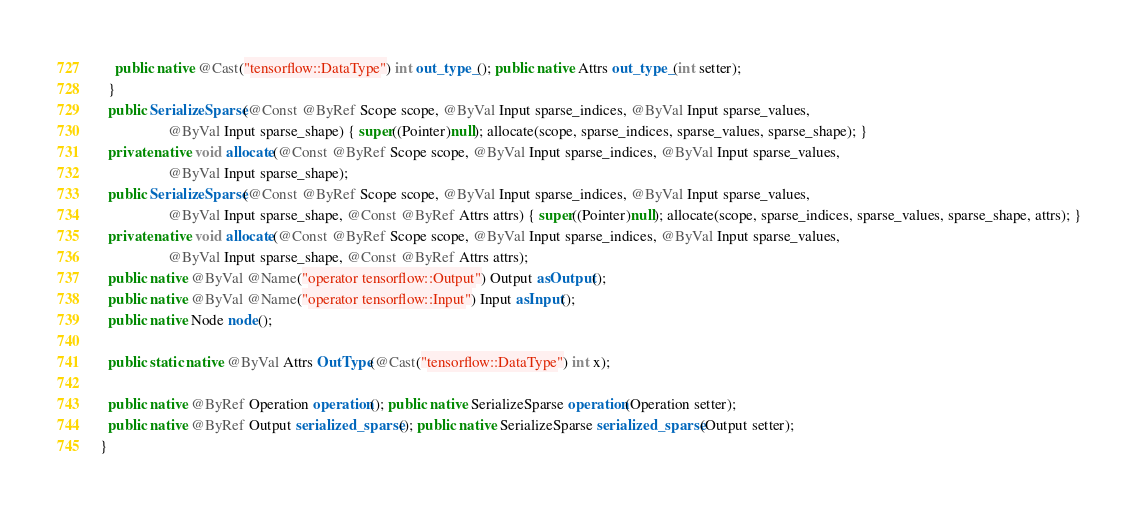Convert code to text. <code><loc_0><loc_0><loc_500><loc_500><_Java_>    public native @Cast("tensorflow::DataType") int out_type_(); public native Attrs out_type_(int setter);
  }
  public SerializeSparse(@Const @ByRef Scope scope, @ByVal Input sparse_indices, @ByVal Input sparse_values,
                  @ByVal Input sparse_shape) { super((Pointer)null); allocate(scope, sparse_indices, sparse_values, sparse_shape); }
  private native void allocate(@Const @ByRef Scope scope, @ByVal Input sparse_indices, @ByVal Input sparse_values,
                  @ByVal Input sparse_shape);
  public SerializeSparse(@Const @ByRef Scope scope, @ByVal Input sparse_indices, @ByVal Input sparse_values,
                  @ByVal Input sparse_shape, @Const @ByRef Attrs attrs) { super((Pointer)null); allocate(scope, sparse_indices, sparse_values, sparse_shape, attrs); }
  private native void allocate(@Const @ByRef Scope scope, @ByVal Input sparse_indices, @ByVal Input sparse_values,
                  @ByVal Input sparse_shape, @Const @ByRef Attrs attrs);
  public native @ByVal @Name("operator tensorflow::Output") Output asOutput();
  public native @ByVal @Name("operator tensorflow::Input") Input asInput();
  public native Node node();

  public static native @ByVal Attrs OutType(@Cast("tensorflow::DataType") int x);

  public native @ByRef Operation operation(); public native SerializeSparse operation(Operation setter);
  public native @ByRef Output serialized_sparse(); public native SerializeSparse serialized_sparse(Output setter);
}
</code> 